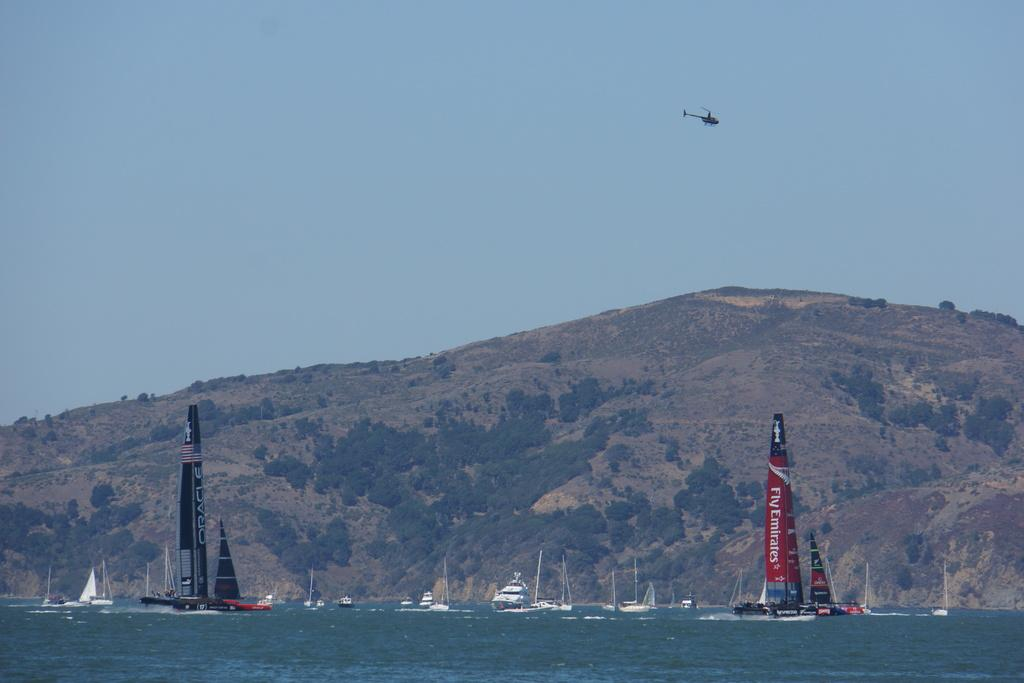Provide a one-sentence caption for the provided image. Fly Emirates is displayed on the sail of this vessel. 